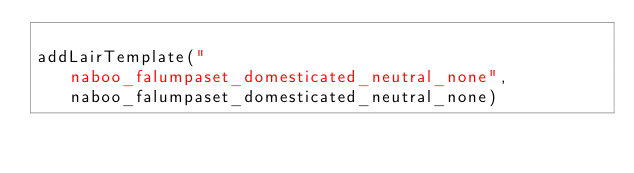<code> <loc_0><loc_0><loc_500><loc_500><_Lua_>
addLairTemplate("naboo_falumpaset_domesticated_neutral_none", naboo_falumpaset_domesticated_neutral_none)
</code> 